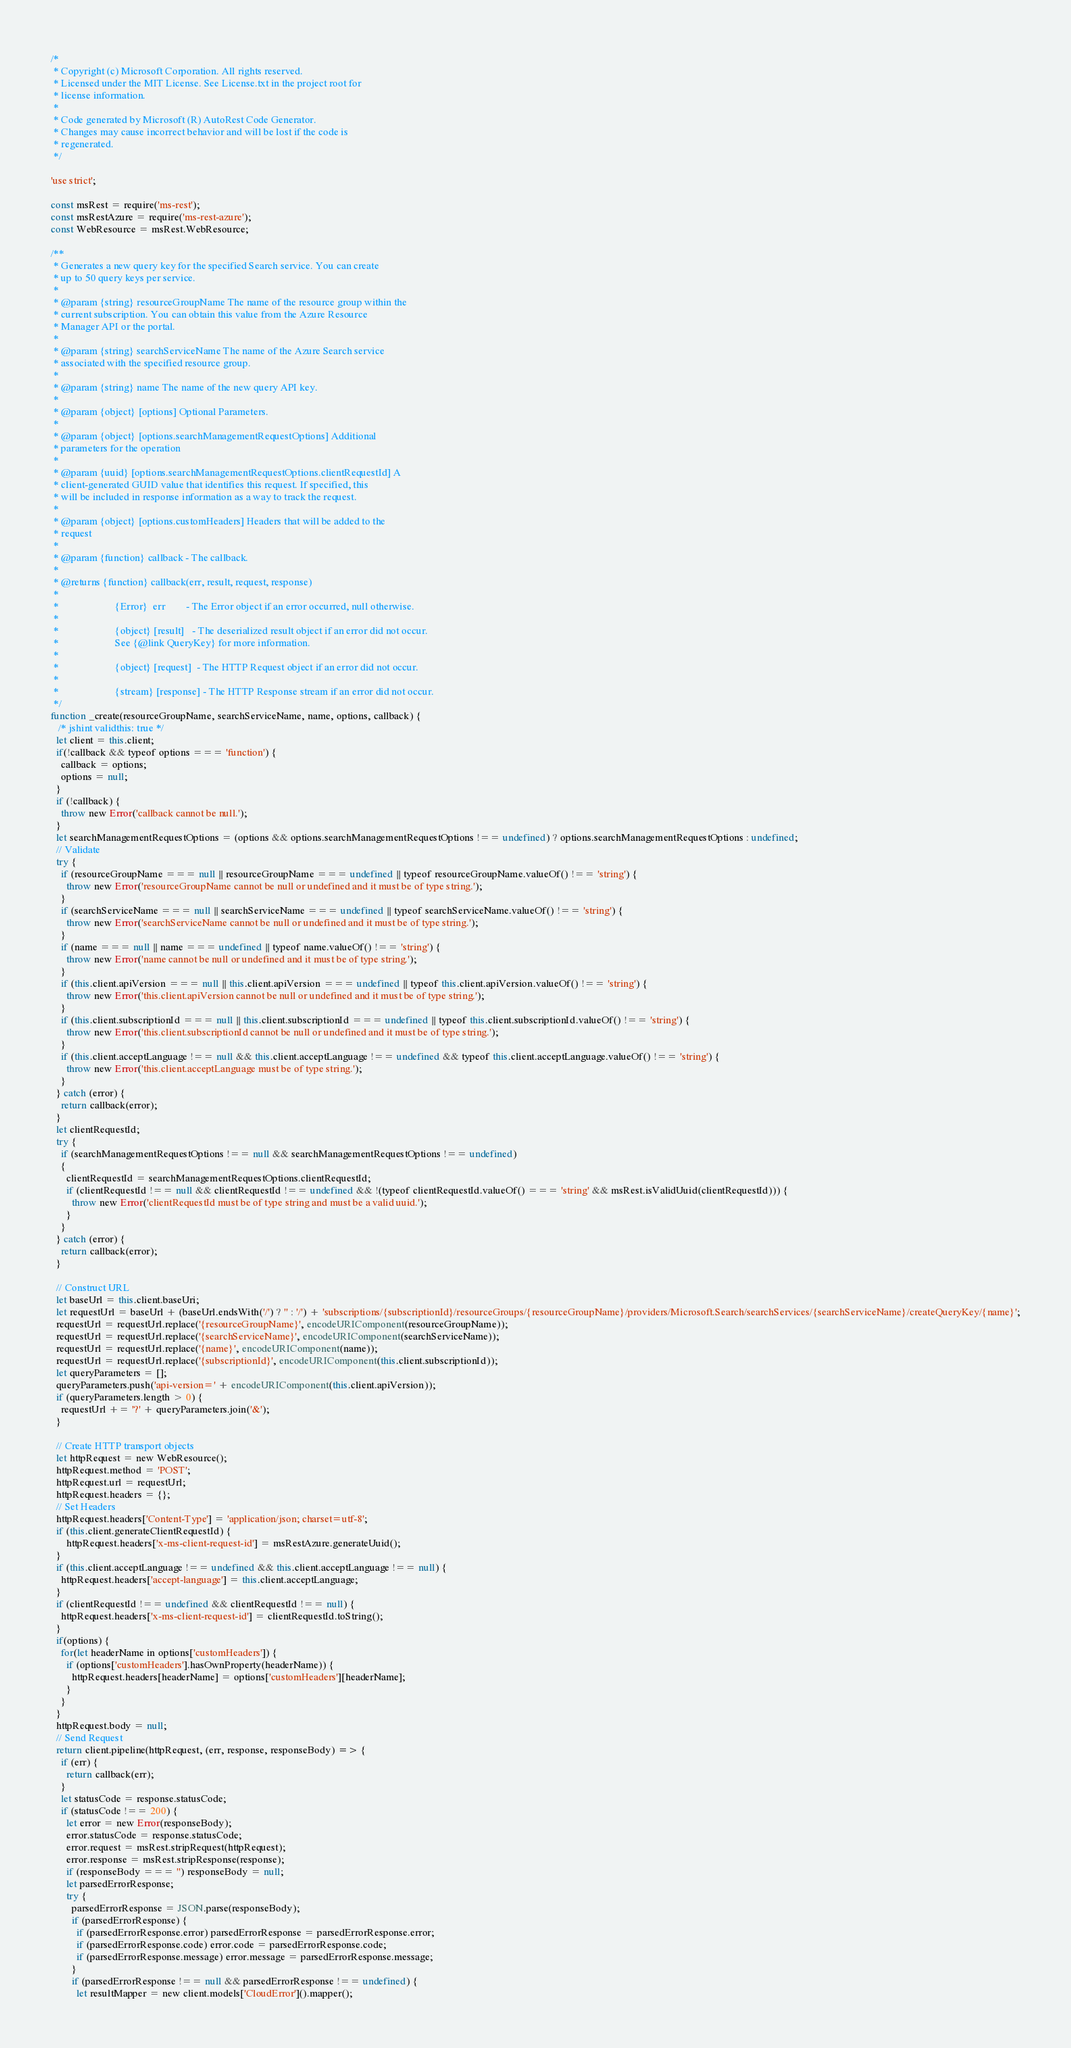<code> <loc_0><loc_0><loc_500><loc_500><_JavaScript_>/*
 * Copyright (c) Microsoft Corporation. All rights reserved.
 * Licensed under the MIT License. See License.txt in the project root for
 * license information.
 *
 * Code generated by Microsoft (R) AutoRest Code Generator.
 * Changes may cause incorrect behavior and will be lost if the code is
 * regenerated.
 */

'use strict';

const msRest = require('ms-rest');
const msRestAzure = require('ms-rest-azure');
const WebResource = msRest.WebResource;

/**
 * Generates a new query key for the specified Search service. You can create
 * up to 50 query keys per service.
 *
 * @param {string} resourceGroupName The name of the resource group within the
 * current subscription. You can obtain this value from the Azure Resource
 * Manager API or the portal.
 *
 * @param {string} searchServiceName The name of the Azure Search service
 * associated with the specified resource group.
 *
 * @param {string} name The name of the new query API key.
 *
 * @param {object} [options] Optional Parameters.
 *
 * @param {object} [options.searchManagementRequestOptions] Additional
 * parameters for the operation
 *
 * @param {uuid} [options.searchManagementRequestOptions.clientRequestId] A
 * client-generated GUID value that identifies this request. If specified, this
 * will be included in response information as a way to track the request.
 *
 * @param {object} [options.customHeaders] Headers that will be added to the
 * request
 *
 * @param {function} callback - The callback.
 *
 * @returns {function} callback(err, result, request, response)
 *
 *                      {Error}  err        - The Error object if an error occurred, null otherwise.
 *
 *                      {object} [result]   - The deserialized result object if an error did not occur.
 *                      See {@link QueryKey} for more information.
 *
 *                      {object} [request]  - The HTTP Request object if an error did not occur.
 *
 *                      {stream} [response] - The HTTP Response stream if an error did not occur.
 */
function _create(resourceGroupName, searchServiceName, name, options, callback) {
   /* jshint validthis: true */
  let client = this.client;
  if(!callback && typeof options === 'function') {
    callback = options;
    options = null;
  }
  if (!callback) {
    throw new Error('callback cannot be null.');
  }
  let searchManagementRequestOptions = (options && options.searchManagementRequestOptions !== undefined) ? options.searchManagementRequestOptions : undefined;
  // Validate
  try {
    if (resourceGroupName === null || resourceGroupName === undefined || typeof resourceGroupName.valueOf() !== 'string') {
      throw new Error('resourceGroupName cannot be null or undefined and it must be of type string.');
    }
    if (searchServiceName === null || searchServiceName === undefined || typeof searchServiceName.valueOf() !== 'string') {
      throw new Error('searchServiceName cannot be null or undefined and it must be of type string.');
    }
    if (name === null || name === undefined || typeof name.valueOf() !== 'string') {
      throw new Error('name cannot be null or undefined and it must be of type string.');
    }
    if (this.client.apiVersion === null || this.client.apiVersion === undefined || typeof this.client.apiVersion.valueOf() !== 'string') {
      throw new Error('this.client.apiVersion cannot be null or undefined and it must be of type string.');
    }
    if (this.client.subscriptionId === null || this.client.subscriptionId === undefined || typeof this.client.subscriptionId.valueOf() !== 'string') {
      throw new Error('this.client.subscriptionId cannot be null or undefined and it must be of type string.');
    }
    if (this.client.acceptLanguage !== null && this.client.acceptLanguage !== undefined && typeof this.client.acceptLanguage.valueOf() !== 'string') {
      throw new Error('this.client.acceptLanguage must be of type string.');
    }
  } catch (error) {
    return callback(error);
  }
  let clientRequestId;
  try {
    if (searchManagementRequestOptions !== null && searchManagementRequestOptions !== undefined)
    {
      clientRequestId = searchManagementRequestOptions.clientRequestId;
      if (clientRequestId !== null && clientRequestId !== undefined && !(typeof clientRequestId.valueOf() === 'string' && msRest.isValidUuid(clientRequestId))) {
        throw new Error('clientRequestId must be of type string and must be a valid uuid.');
      }
    }
  } catch (error) {
    return callback(error);
  }

  // Construct URL
  let baseUrl = this.client.baseUri;
  let requestUrl = baseUrl + (baseUrl.endsWith('/') ? '' : '/') + 'subscriptions/{subscriptionId}/resourceGroups/{resourceGroupName}/providers/Microsoft.Search/searchServices/{searchServiceName}/createQueryKey/{name}';
  requestUrl = requestUrl.replace('{resourceGroupName}', encodeURIComponent(resourceGroupName));
  requestUrl = requestUrl.replace('{searchServiceName}', encodeURIComponent(searchServiceName));
  requestUrl = requestUrl.replace('{name}', encodeURIComponent(name));
  requestUrl = requestUrl.replace('{subscriptionId}', encodeURIComponent(this.client.subscriptionId));
  let queryParameters = [];
  queryParameters.push('api-version=' + encodeURIComponent(this.client.apiVersion));
  if (queryParameters.length > 0) {
    requestUrl += '?' + queryParameters.join('&');
  }

  // Create HTTP transport objects
  let httpRequest = new WebResource();
  httpRequest.method = 'POST';
  httpRequest.url = requestUrl;
  httpRequest.headers = {};
  // Set Headers
  httpRequest.headers['Content-Type'] = 'application/json; charset=utf-8';
  if (this.client.generateClientRequestId) {
      httpRequest.headers['x-ms-client-request-id'] = msRestAzure.generateUuid();
  }
  if (this.client.acceptLanguage !== undefined && this.client.acceptLanguage !== null) {
    httpRequest.headers['accept-language'] = this.client.acceptLanguage;
  }
  if (clientRequestId !== undefined && clientRequestId !== null) {
    httpRequest.headers['x-ms-client-request-id'] = clientRequestId.toString();
  }
  if(options) {
    for(let headerName in options['customHeaders']) {
      if (options['customHeaders'].hasOwnProperty(headerName)) {
        httpRequest.headers[headerName] = options['customHeaders'][headerName];
      }
    }
  }
  httpRequest.body = null;
  // Send Request
  return client.pipeline(httpRequest, (err, response, responseBody) => {
    if (err) {
      return callback(err);
    }
    let statusCode = response.statusCode;
    if (statusCode !== 200) {
      let error = new Error(responseBody);
      error.statusCode = response.statusCode;
      error.request = msRest.stripRequest(httpRequest);
      error.response = msRest.stripResponse(response);
      if (responseBody === '') responseBody = null;
      let parsedErrorResponse;
      try {
        parsedErrorResponse = JSON.parse(responseBody);
        if (parsedErrorResponse) {
          if (parsedErrorResponse.error) parsedErrorResponse = parsedErrorResponse.error;
          if (parsedErrorResponse.code) error.code = parsedErrorResponse.code;
          if (parsedErrorResponse.message) error.message = parsedErrorResponse.message;
        }
        if (parsedErrorResponse !== null && parsedErrorResponse !== undefined) {
          let resultMapper = new client.models['CloudError']().mapper();</code> 